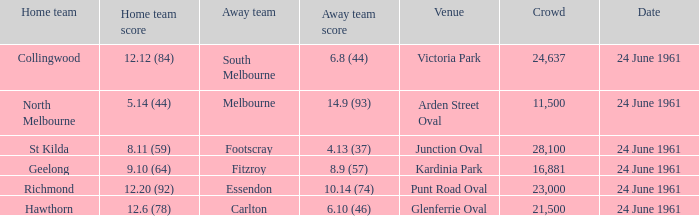Who was the home team that scored 12.6 (78)? Hawthorn. 